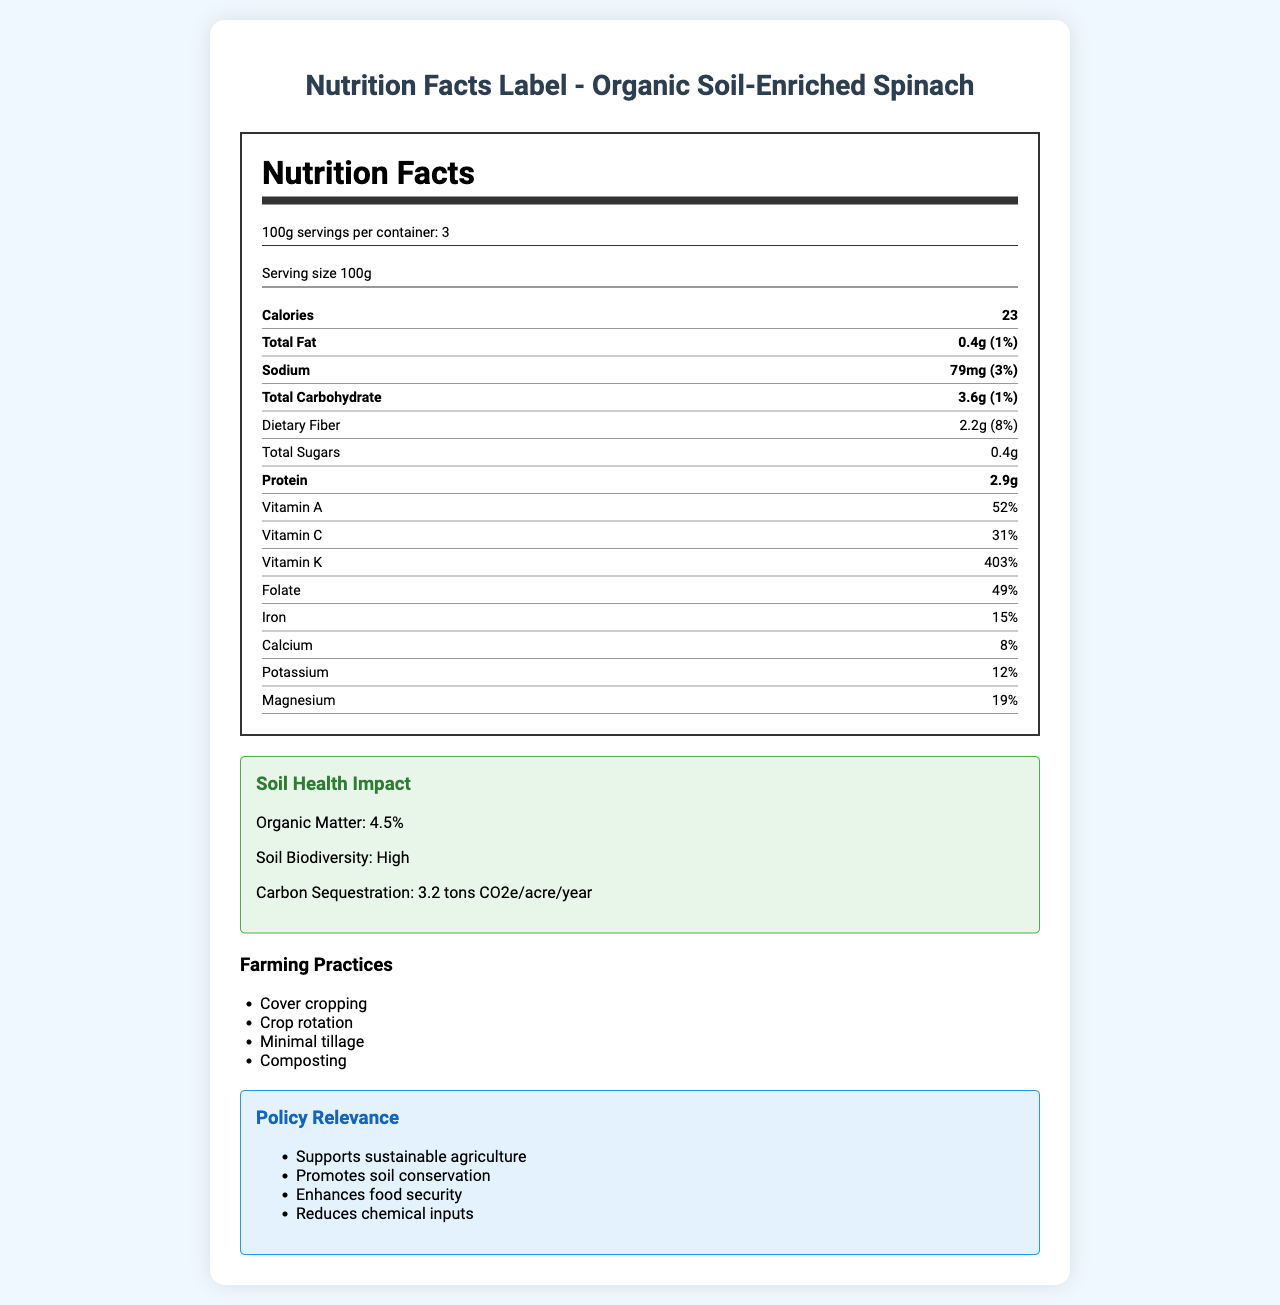what is the serving size of the Organic Soil-Enriched Spinach? The serving size is explicitly mentioned as "100g" in the document.
Answer: 100g how many servings are there per container? The document states that there are 3 servings per container.
Answer: 3 what is the amount of total fat per serving? The total fat per serving is specified as "0.4g" in the document.
Answer: 0.4g what percentage of the daily value of vitamin A does one serving contain? The document lists the daily value percentage of vitamin A as 52%.
Answer: 52% what are the farming practices used for the production of the spinach? The farming practices section lists these four methods.
Answer: Cover cropping, Crop rotation, Minimal tillage, Composting how much sodium is in one serving? A. 50mg B. 79mg C. 100mg The sodium content per serving is 79mg, as specified in the document.
Answer: B which of the following is not listed as a consumer health benefit? A. Lower pesticide residues B. Increased omega-3 content C. Higher antioxidant content D. Increased phytonutrients The document lists "Higher antioxidant content," "Increased phytonutrients," and "Lower pesticide residues" as consumer health benefits but does not mention "Increased omega-3 content."
Answer: B does this product have a USDA Organic certification? The document explicitly states that the product has USDA Organic certification.
Answer: Yes summarize the main idea of the document. This summary captures the core aspects of the document, including the detailed nutrition facts, soil health impact, sustainable farming practices, policy relevance, and associated benefits.
Answer: The document provides detailed nutritional information, soil health impact, farming practices, and economic/environmental benefits for Organic Soil-Enriched Spinach. It highlights the positive outcomes of sustainable farming practices on both the product's nutrient density and broader ecological and economic benefits. what is the exact farm location where the spinach is grown? The document mentions that the farm location is Salinas Valley, California.
Answer: Salinas Valley, California what is the economic impact on farm income from producing this spinach? The document states that the farm income increased by 15% compared to conventional farming practices.
Answer: +15% compared to conventional what is the nutrient density score of the Organic Soil-Enriched Spinach? The nutrient density score is listed as 92 in the document.
Answer: 92 what is the daily value percentage of iron provided by one serving? The document states that one serving provides 15% of the daily value for iron.
Answer: 15% how much carbon sequestration is achieved per acre per year? The document specifies that 3.2 tons of CO2 equivalent are sequestered per acre per year.
Answer: 3.2 tons CO2e/acre/year did the farming practices used increase local employment in the agricultural sector? The document indicates local employment increased by 8% in the agricultural sector.
Answer: Yes how does the spinach contribute to environmental benefits? The document lists these specific environmental benefits under the environmental benefits section.
Answer: Increased water retention, Reduced soil erosion, Enhanced pollinator habitat, Improved air quality what's the total carbohydrate content in one serving of the spinach? The total carbohydrate content per serving is specified as 3.6g.
Answer: 3.6g is the information on soil biodiversity quantitative or qualitative? The document describes soil biodiversity as "High," which is a qualitative descriptor.
Answer: Qualitative how many grams of dietary fiber are there in one serving? The dietary fiber content per serving is 2.2g, as stated in the document.
Answer: 2.2g what impact does the product have on food security? The document mentions that the product promotes soil conservation and enhances food security among other benefits.
Answer: Enhances food security what is the antioxidant content? The document states the product has higher antioxidant content but does not quantify the amount.
Answer: Not enough information 